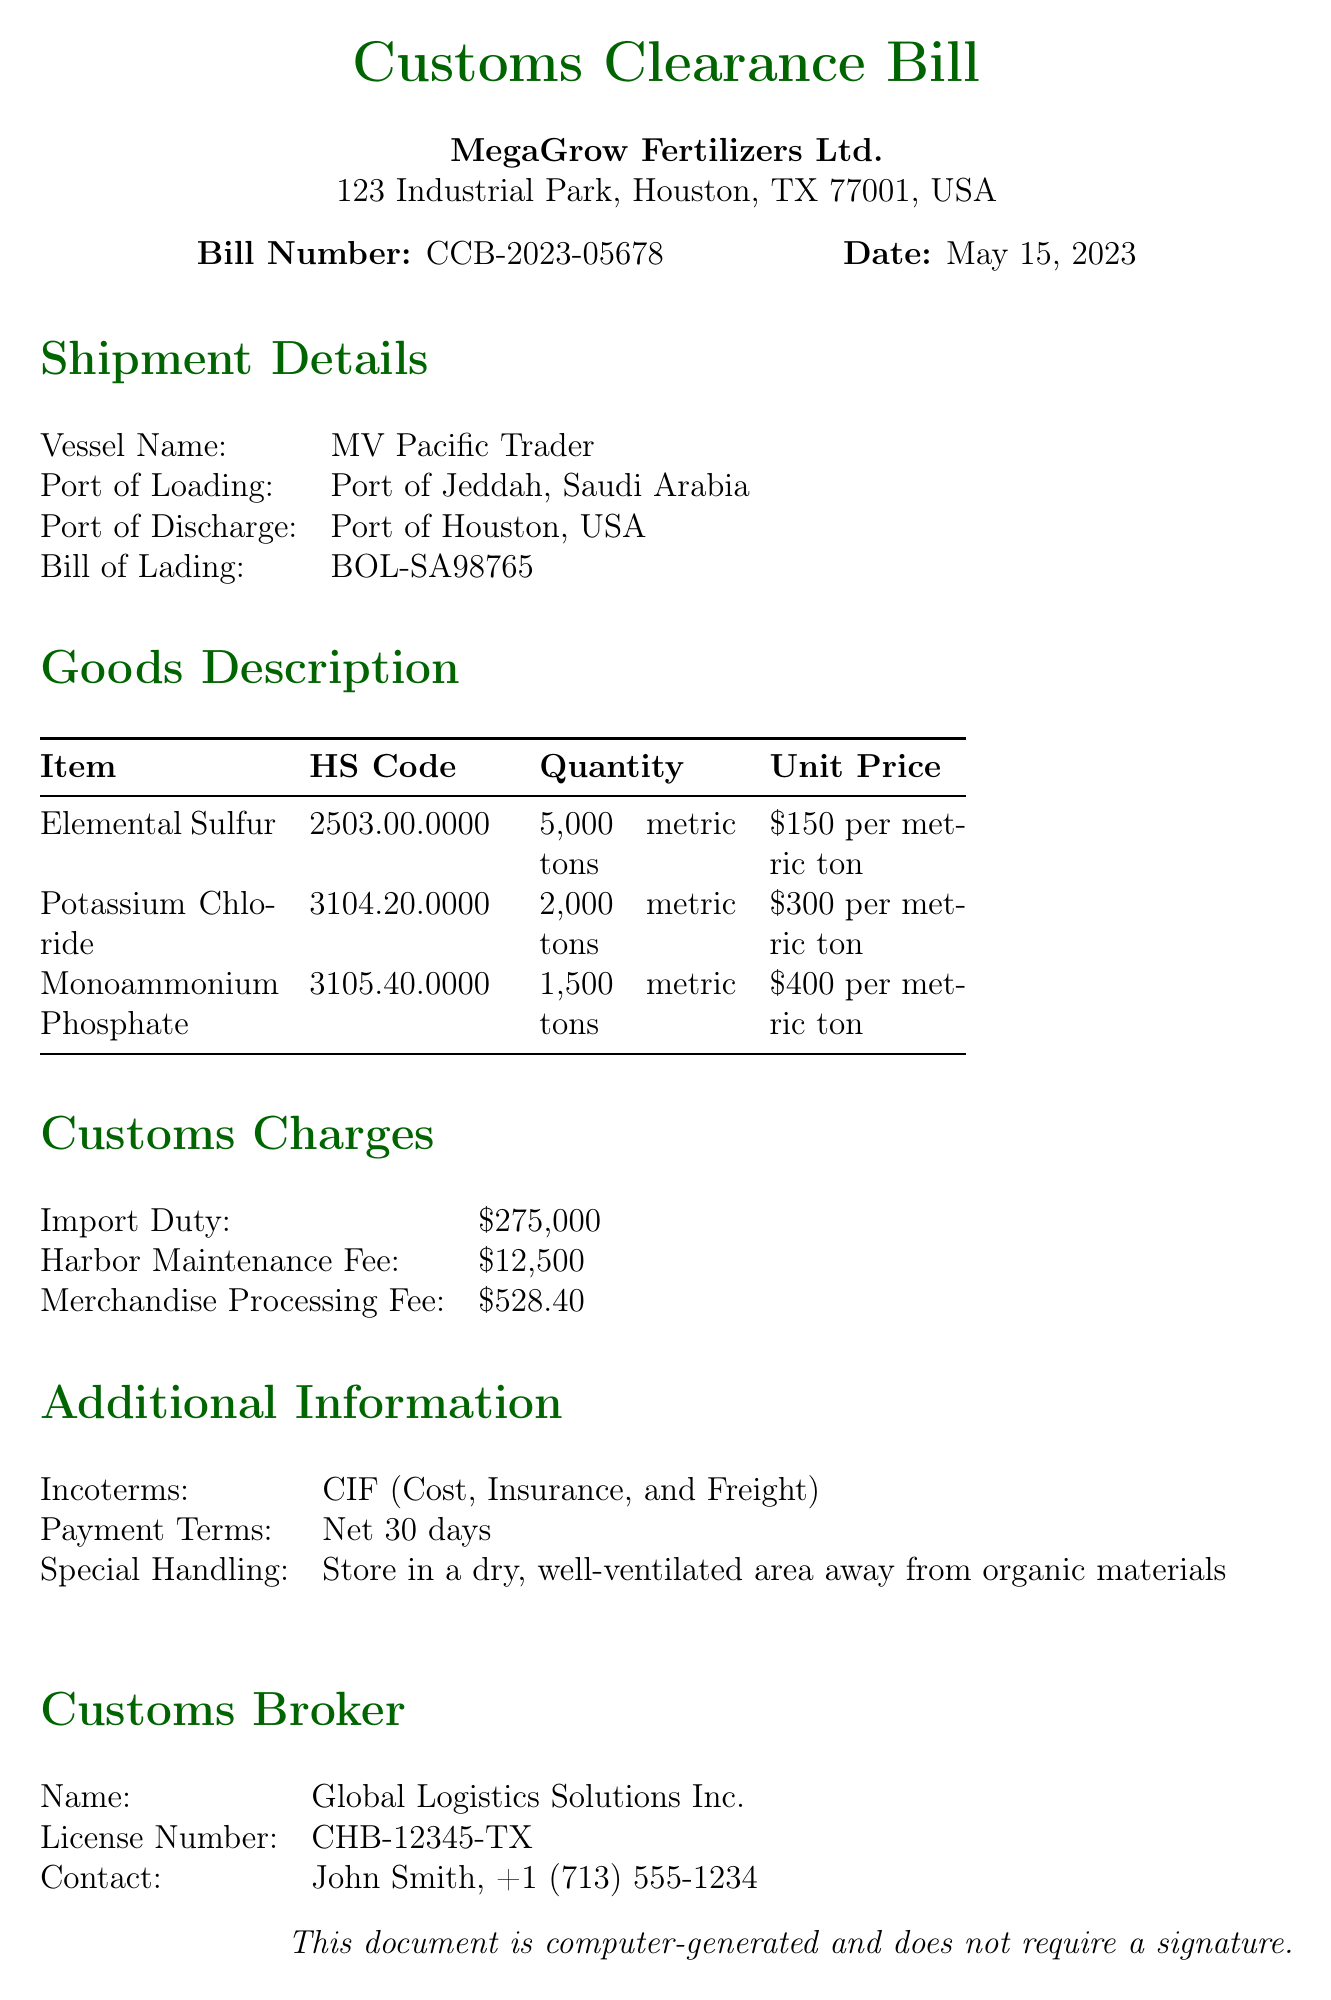What is the bill number? The bill number is specified in the document, which is CCB-2023-05678.
Answer: CCB-2023-05678 When was the customs clearance bill dated? The date of the bill is clearly stated, which is May 15, 2023.
Answer: May 15, 2023 What is the quantity of Elemental Sulfur being imported? The quantity listed for Elemental Sulfur is 5,000 metric tons in the goods description.
Answer: 5,000 metric tons What is the total import duty charged? The total import duty amount is mentioned in the customs charges section, which is $275,000.
Answer: $275,000 What is the contact number for the customs broker? The contact number for Global Logistics Solutions Inc., the customs broker, is provided as +1 (713) 555-1234.
Answer: +1 (713) 555-1234 What is the Incoterm used for this shipment? The incoterm specified in the additional information is CIF, which stands for Cost, Insurance, and Freight.
Answer: CIF What is the unit price of Potassium Chloride? The document states that the unit price for Potassium Chloride is $300 per metric ton.
Answer: $300 per metric ton Who is the customs broker for this shipment? The name of the customs broker listed is Global Logistics Solutions Inc.
Answer: Global Logistics Solutions Inc What is the special handling instruction for the goods? The special handling instruction provided states to store the goods in a dry, well-ventilated area away from organic materials.
Answer: Store in a dry, well-ventilated area away from organic materials 